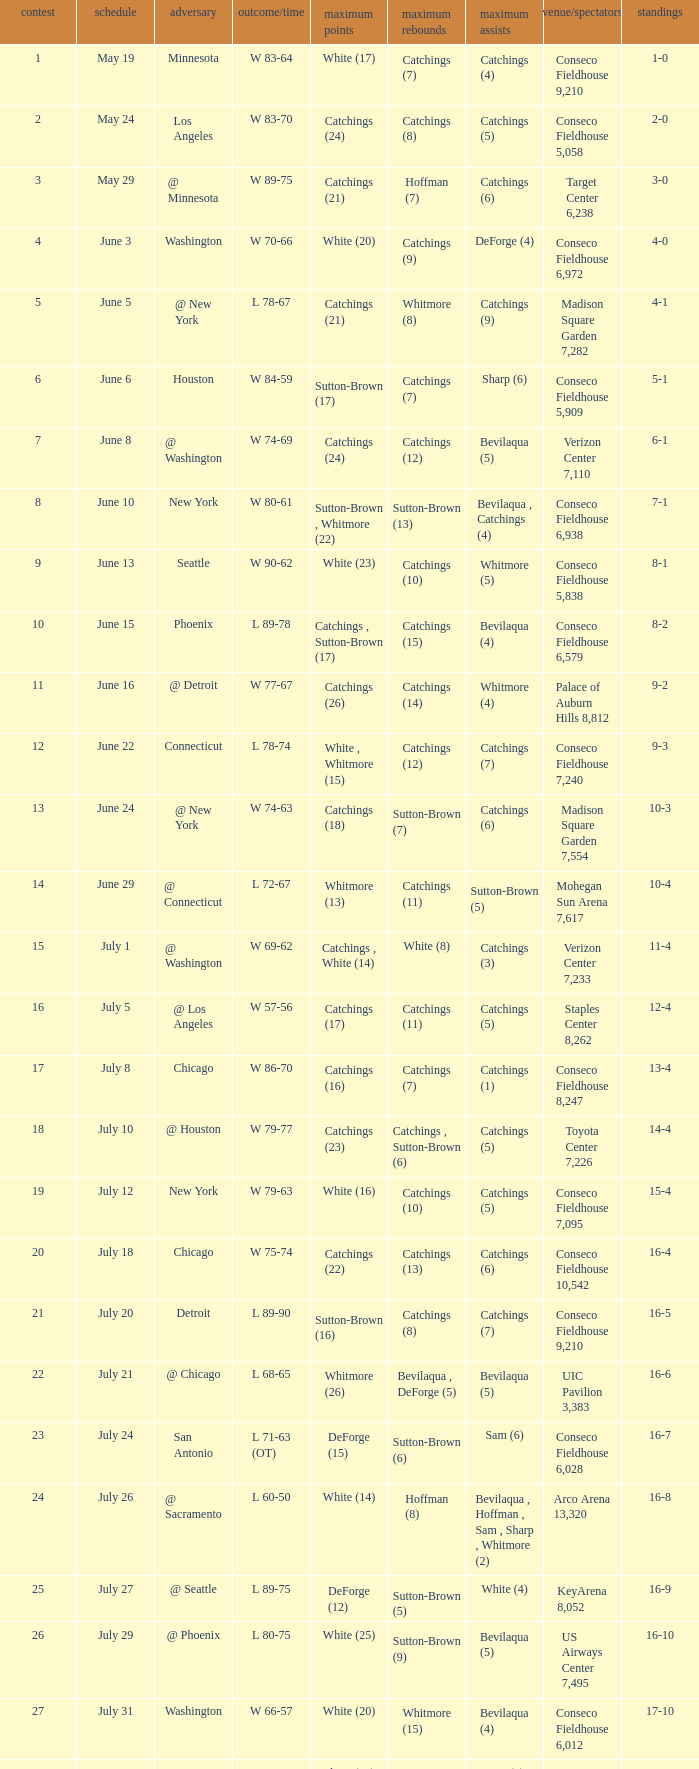Name the date where score time is w 74-63 June 24. 